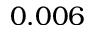Convert formula to latex. <formula><loc_0><loc_0><loc_500><loc_500>0 . 0 0 6</formula> 